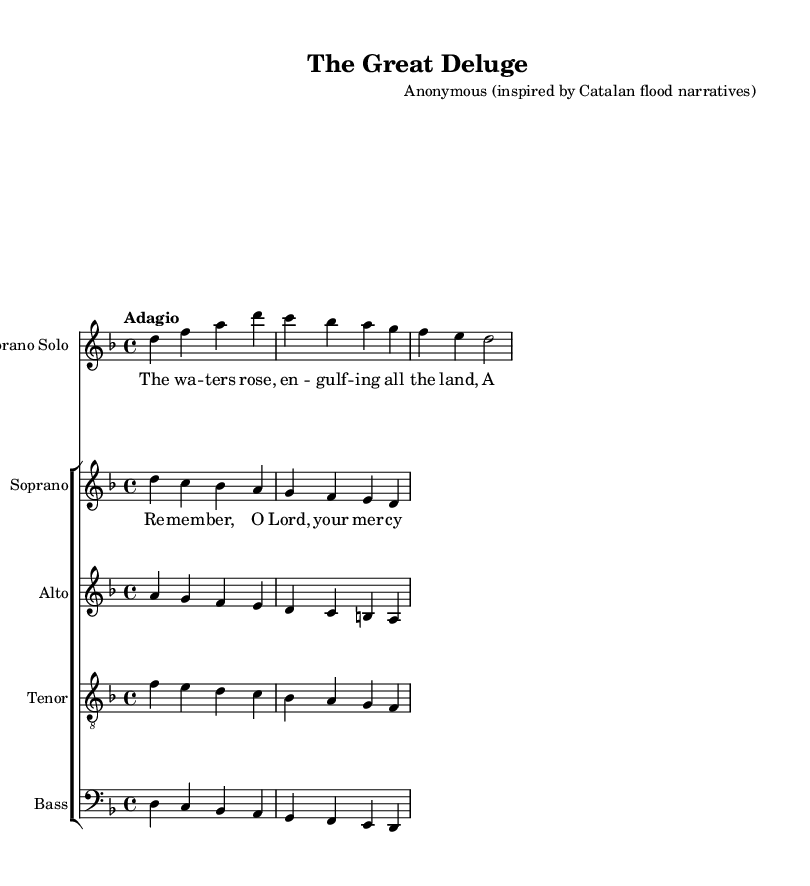What is the key signature of this music? The key signature is indicated by the sharps or flats at the beginning of the staff. In this case, it shows one flat, which corresponds to D minor.
Answer: D minor What is the time signature of this music? The time signature is located at the beginning of the staff, written as a fraction. Here, it is noted as four beats per measure, written as 4/4.
Answer: 4/4 What is the tempo marking for this piece? The tempo marking is indicated at the start of the music and suggests the speed for performing it. In this example, it is marked as "Adagio."
Answer: Adagio What type of voice sings the soprano solo part? The designation shows that it is a solo part, specifically marked within the sheet music for Highland soloists.
Answer: Soprano Solo How many vocal parts are included in the choir? By examining the choir staff, we can count the individual voices listed there: soprano, alto, tenor, and bass, which totals four parts.
Answer: Four What is the theme depicted in the lyrics? By reading the lyrics provided, it suggests a narrative about rising waters and memories, reflecting a biblical flood story.
Answer: Flood memories Which composer is credited with this piece? The composer’s name is detailed in the header section of the sheet music. It is listed as anonymous, with an inspiration from Catalan flood narratives.
Answer: Anonymous (inspired by Catalan flood narratives) 